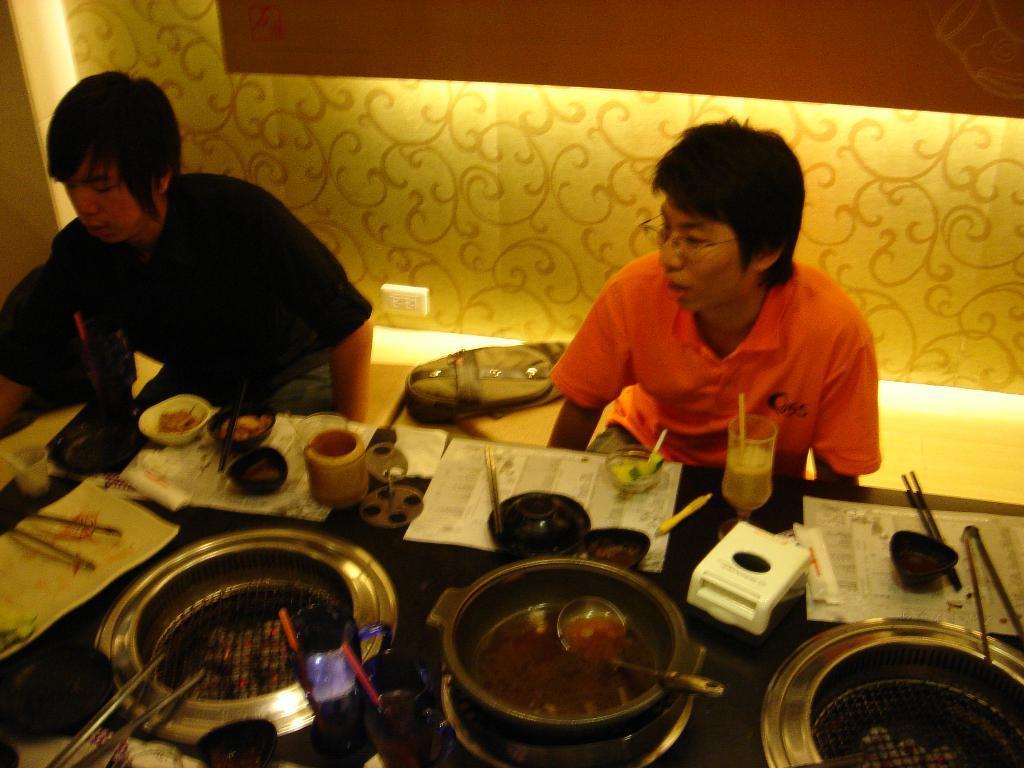Please provide a concise description of this image. In this picture I can see couple of them seated and I can see few bowls, glasses and vessels and few papers, chopsticks on the table and I can see few serving spoons and I can see a backpack. 